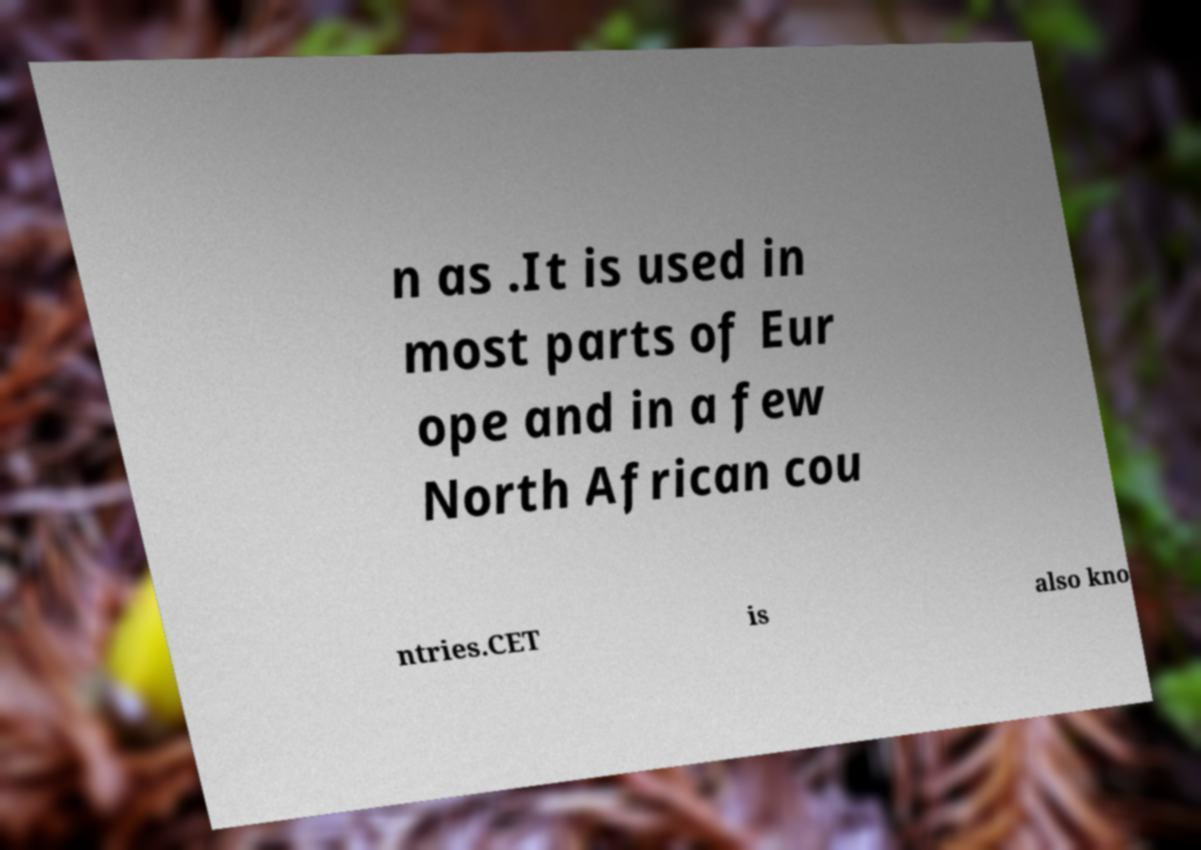Can you accurately transcribe the text from the provided image for me? n as .It is used in most parts of Eur ope and in a few North African cou ntries.CET is also kno 